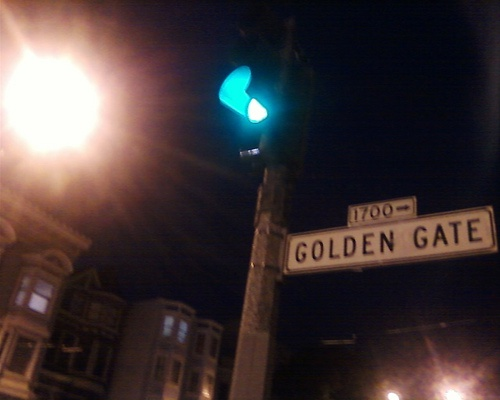Describe the objects in this image and their specific colors. I can see a traffic light in tan, cyan, blue, and teal tones in this image. 